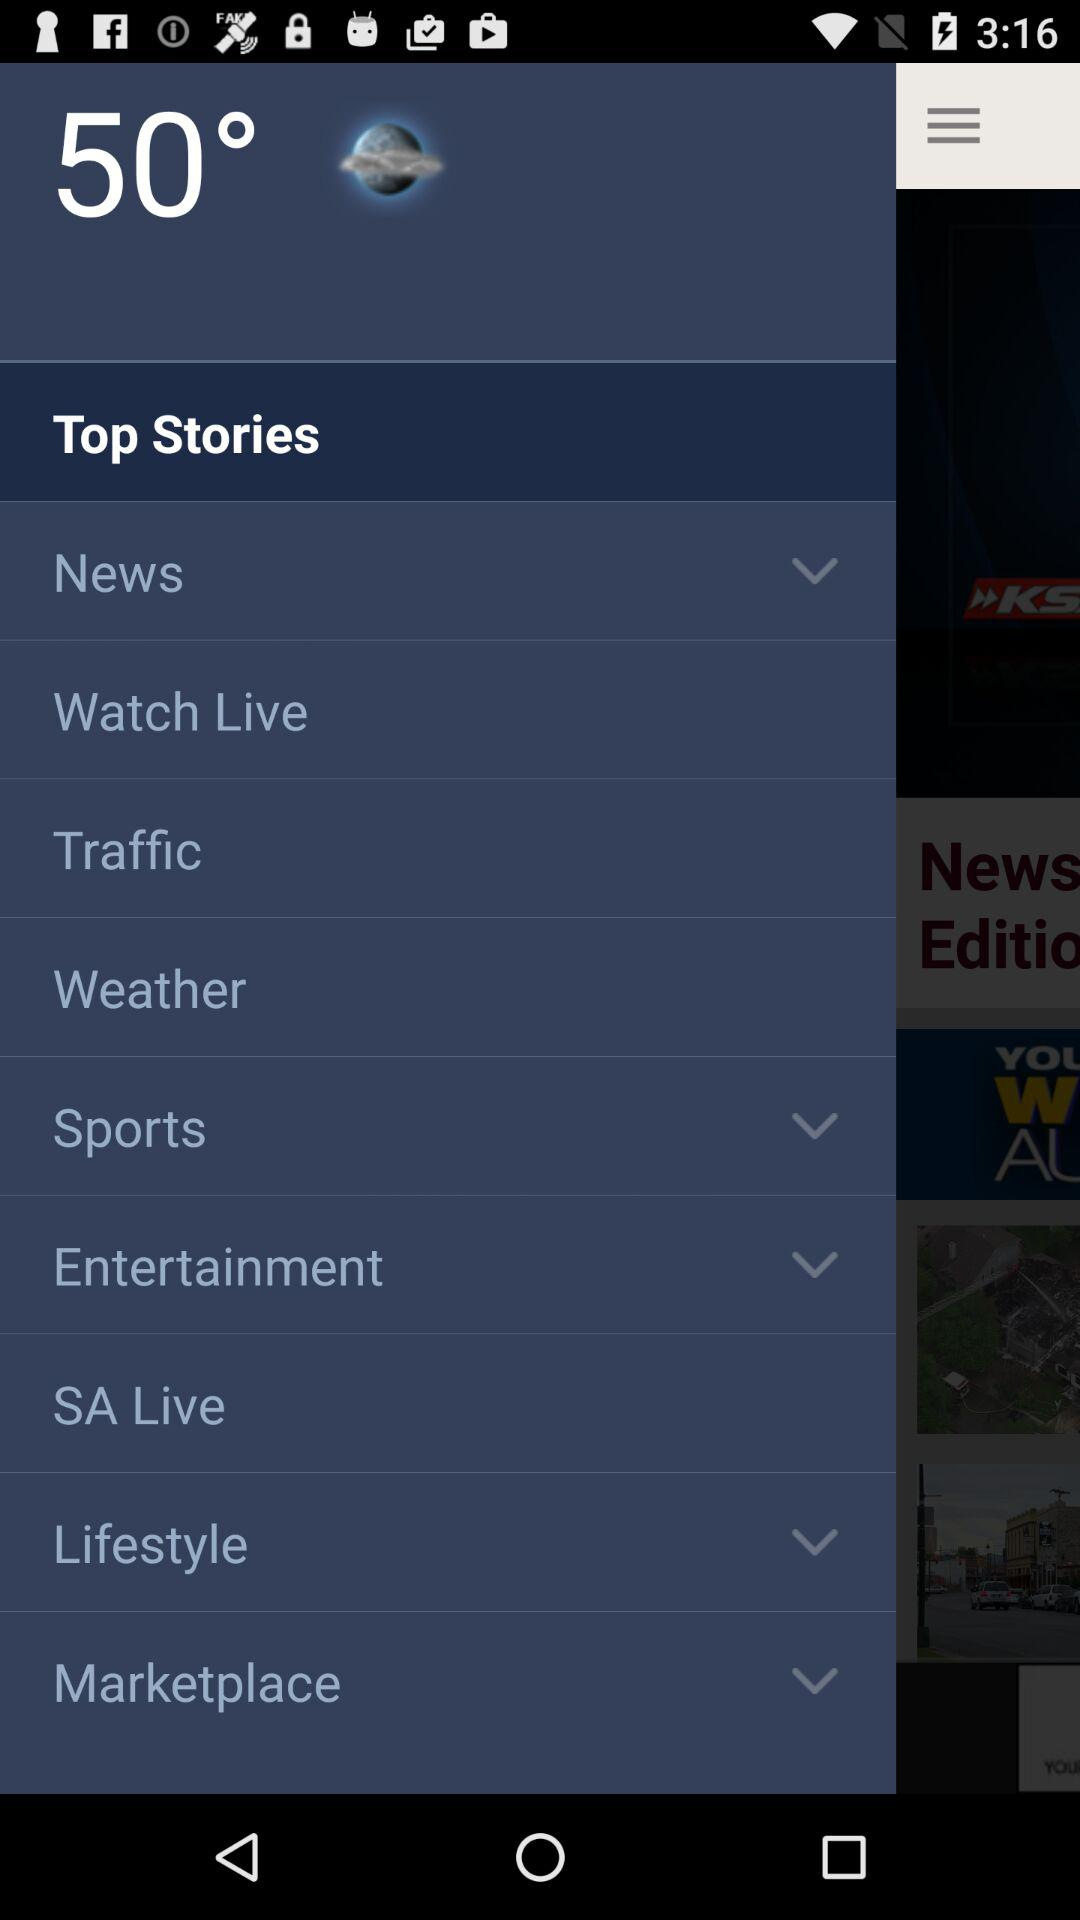What is the temperature? The temperature is 50°. 